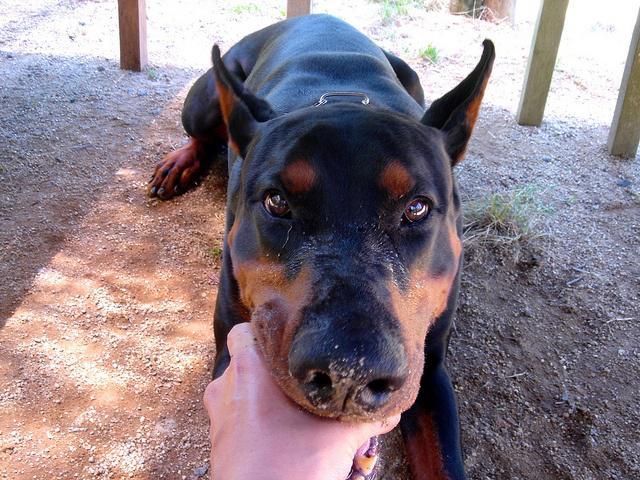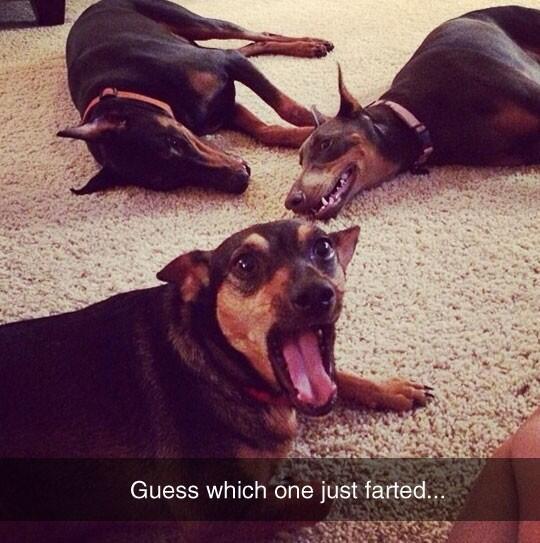The first image is the image on the left, the second image is the image on the right. Evaluate the accuracy of this statement regarding the images: "The left image contains one adult doberman with erect ears and its face straight ahead, and the right image includes at least one doberman reclining on something soft.". Is it true? Answer yes or no. Yes. The first image is the image on the left, the second image is the image on the right. Given the left and right images, does the statement "The left and right image contains the same number of dogs, one being a puppy and the other being an adult." hold true? Answer yes or no. No. 